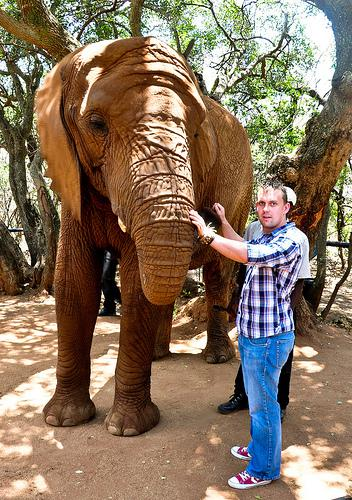Question: what direction are the elephants ears going?
Choices:
A. To the sides.
B. Forward.
C. Left.
D. Back.
Answer with the letter. Answer: D Question: when did this picture get taken?
Choices:
A. 1:15 pm.
B. Morning.
C. Night.
D. Daytime.
Answer with the letter. Answer: D Question: where are the trees?
Choices:
A. Behind zebra.
B. Behind giraffe.
C. Behind elephant.
D. Near the animals.
Answer with the letter. Answer: C Question: who is wearing a checkered shirt?
Choices:
A. Man front.
B. Motorcyclist.
C. Man in grey suit.
D. Man at table.
Answer with the letter. Answer: A 